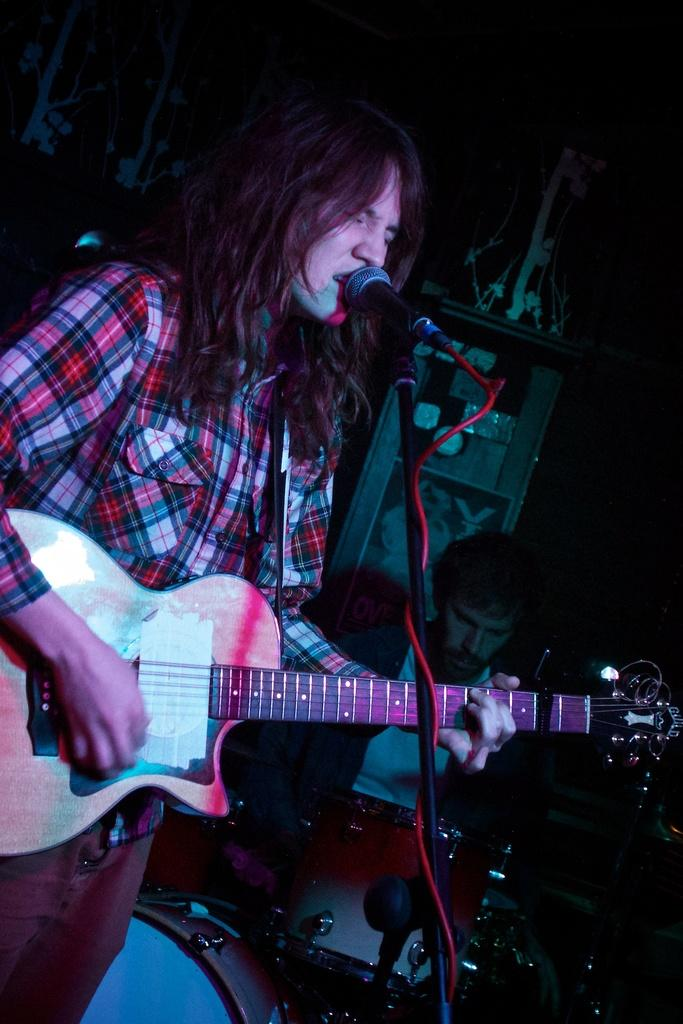What is the person in the image holding? The person is holding a guitar in the image. What is the person doing with the guitar? The person is playing the guitar. What other activity is the person engaged in? The person is singing. What object is present for amplifying the person's voice? There is a microphone in the image. Can you describe the other person in the image? The other person in the background is playing drums. What type of birds can be seen perched on the mountain in the image? There is no mountain or birds present in the image. Is there a sofa in the image where the person can sit and play the guitar? There is no sofa present in the image. 